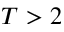<formula> <loc_0><loc_0><loc_500><loc_500>T > 2</formula> 